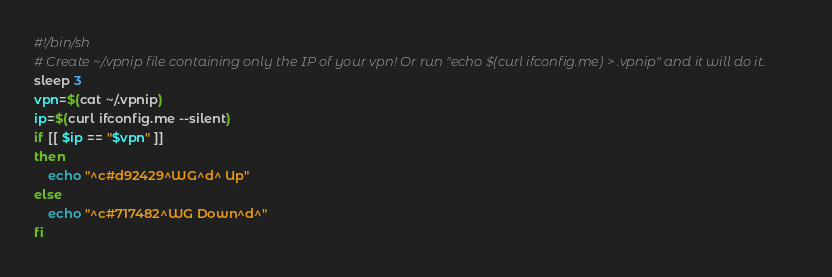Convert code to text. <code><loc_0><loc_0><loc_500><loc_500><_Bash_>#!/bin/sh
# Create ~/.vpnip file containing only the IP of your vpn! Or run "echo $(curl ifconfig.me) > .vpnip" and it will do it.
sleep 3
vpn=$(cat ~/.vpnip)
ip=$(curl ifconfig.me --silent)
if [[ $ip == "$vpn" ]]
then
    echo "^c#d92429^WG^d^ Up"
else
    echo "^c#717482^WG Down^d^"
fi
</code> 